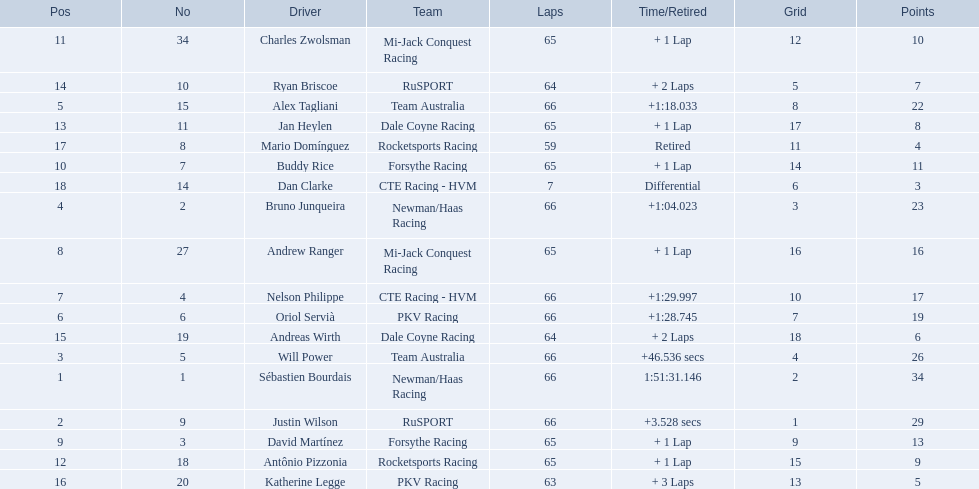Who are all the drivers? Sébastien Bourdais, Justin Wilson, Will Power, Bruno Junqueira, Alex Tagliani, Oriol Servià, Nelson Philippe, Andrew Ranger, David Martínez, Buddy Rice, Charles Zwolsman, Antônio Pizzonia, Jan Heylen, Ryan Briscoe, Andreas Wirth, Katherine Legge, Mario Domínguez, Dan Clarke. What position did they reach? 1, 2, 3, 4, 5, 6, 7, 8, 9, 10, 11, 12, 13, 14, 15, 16, 17, 18. What is the number for each driver? 1, 9, 5, 2, 15, 6, 4, 27, 3, 7, 34, 18, 11, 10, 19, 20, 8, 14. And which player's number and position match? Sébastien Bourdais. 